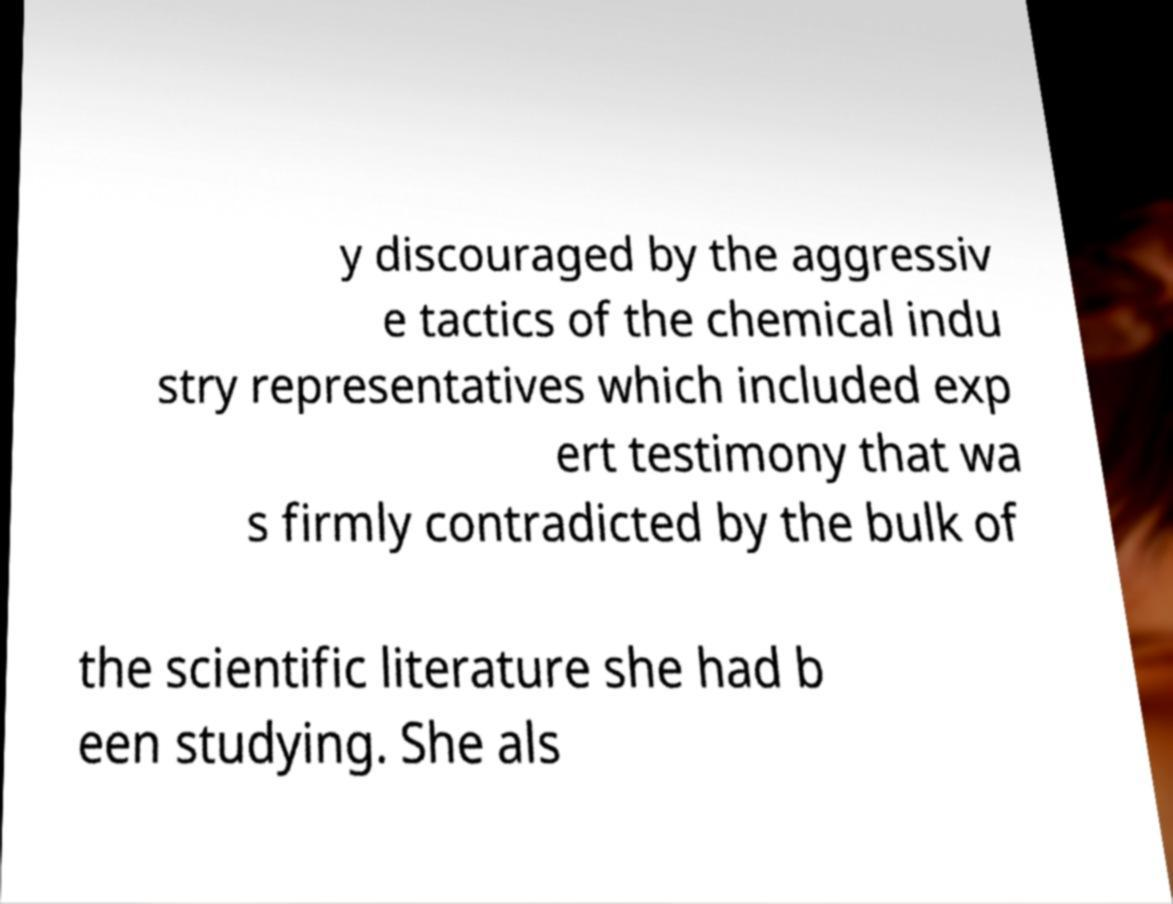Please identify and transcribe the text found in this image. y discouraged by the aggressiv e tactics of the chemical indu stry representatives which included exp ert testimony that wa s firmly contradicted by the bulk of the scientific literature she had b een studying. She als 